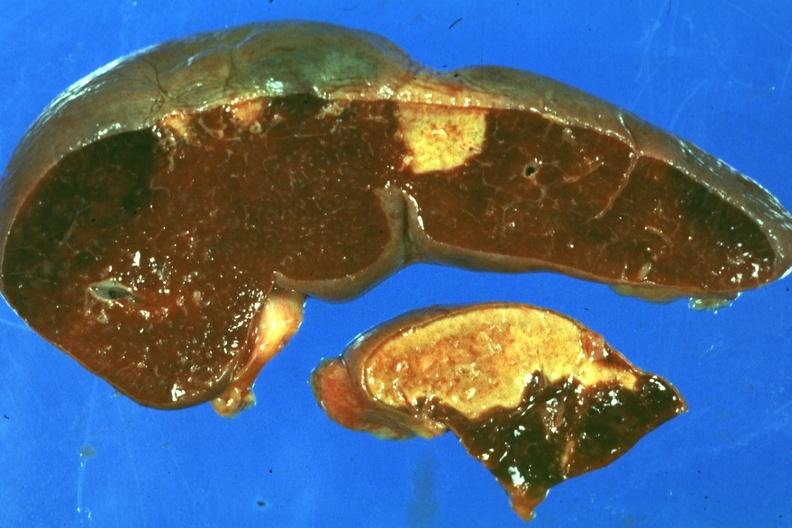what is present?
Answer the question using a single word or phrase. Hematologic 